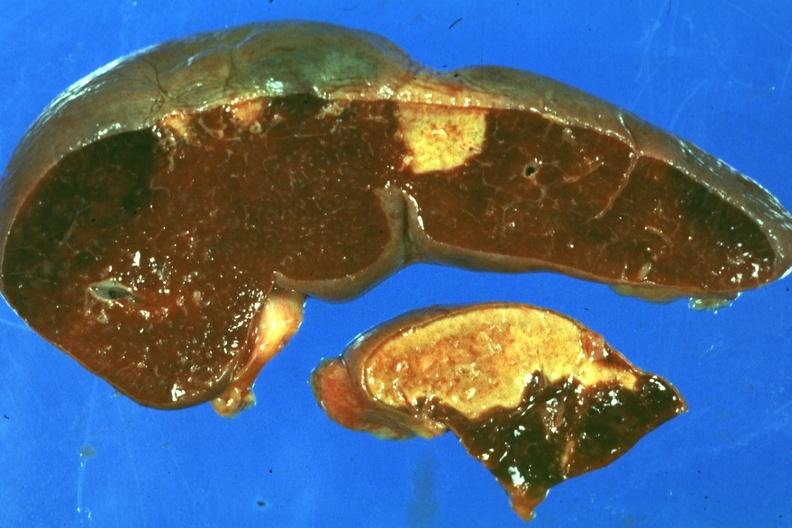what is present?
Answer the question using a single word or phrase. Hematologic 